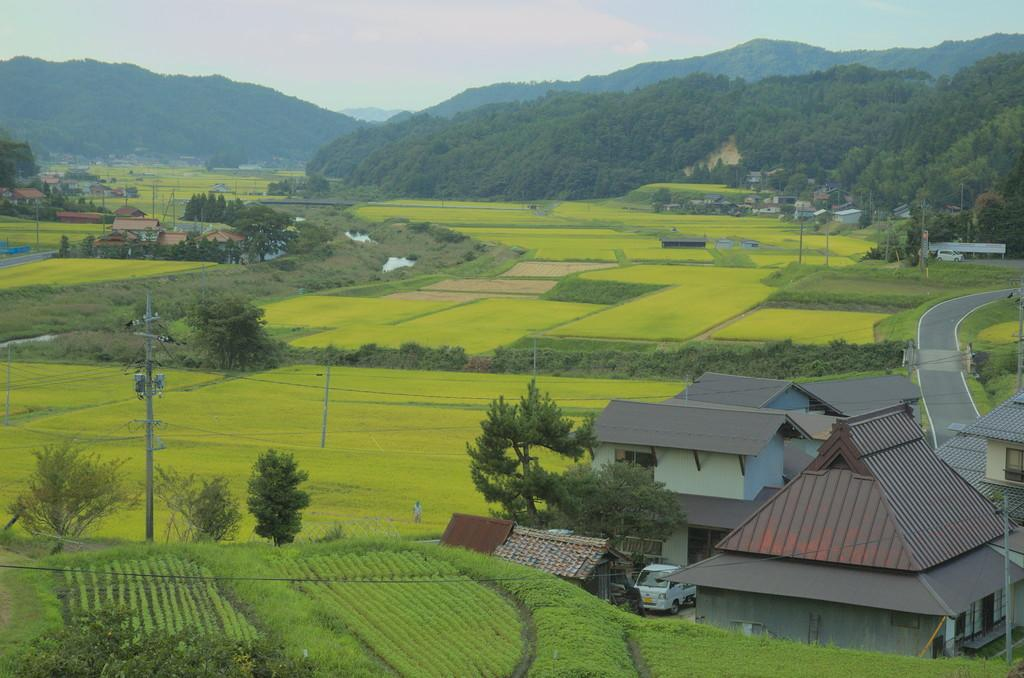What can be seen on both sides of the image? There are houses on both the right and left sides of the image. What type of environment is depicted in the image? There is greenery around the area of the image. What type of sign can be seen on the sink in the image? There is no sink or sign present in the image. 